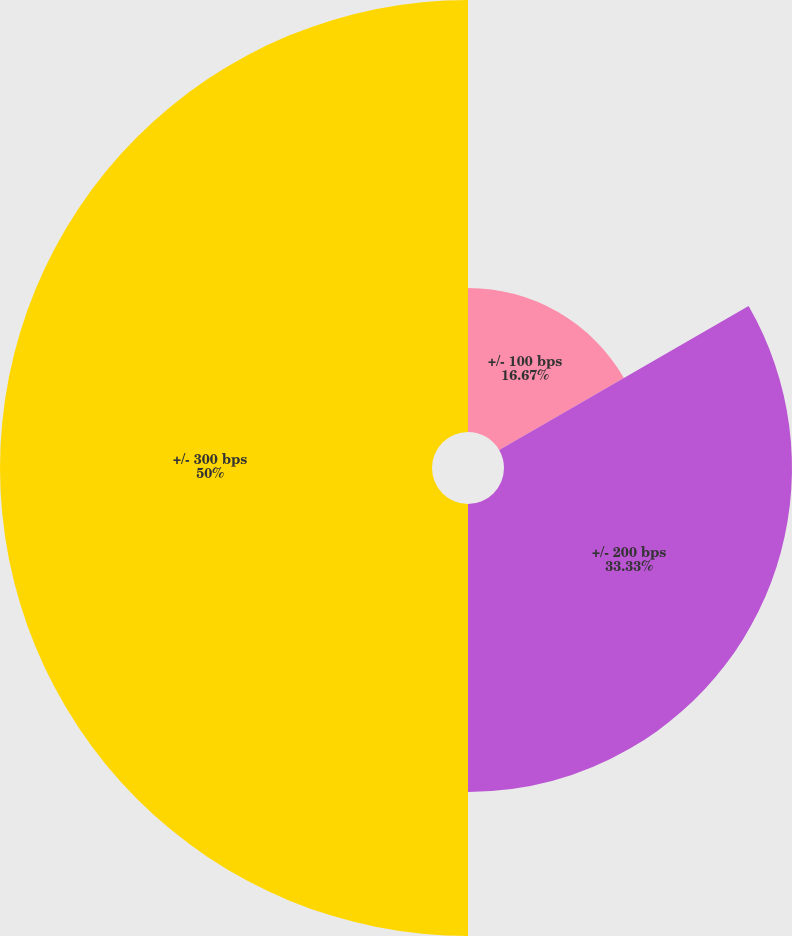Convert chart. <chart><loc_0><loc_0><loc_500><loc_500><pie_chart><fcel>+/- 100 bps<fcel>+/- 200 bps<fcel>+/- 300 bps<nl><fcel>16.67%<fcel>33.33%<fcel>50.0%<nl></chart> 